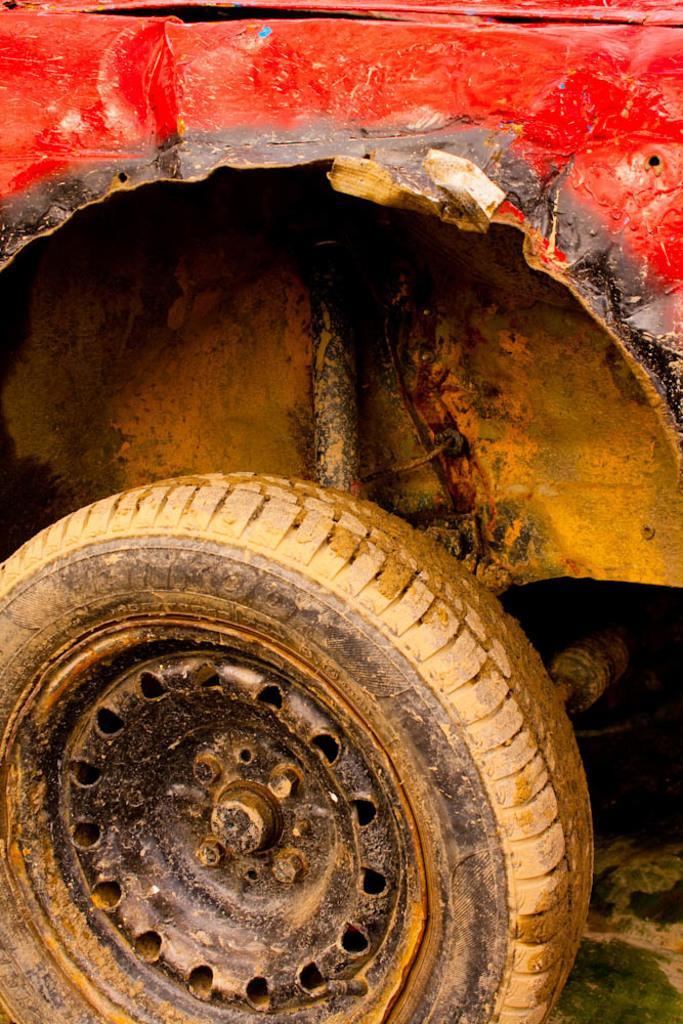Describe this image in one or two sentences. In this image we can see a car and a Tyre attached to it is placed on the ground. 